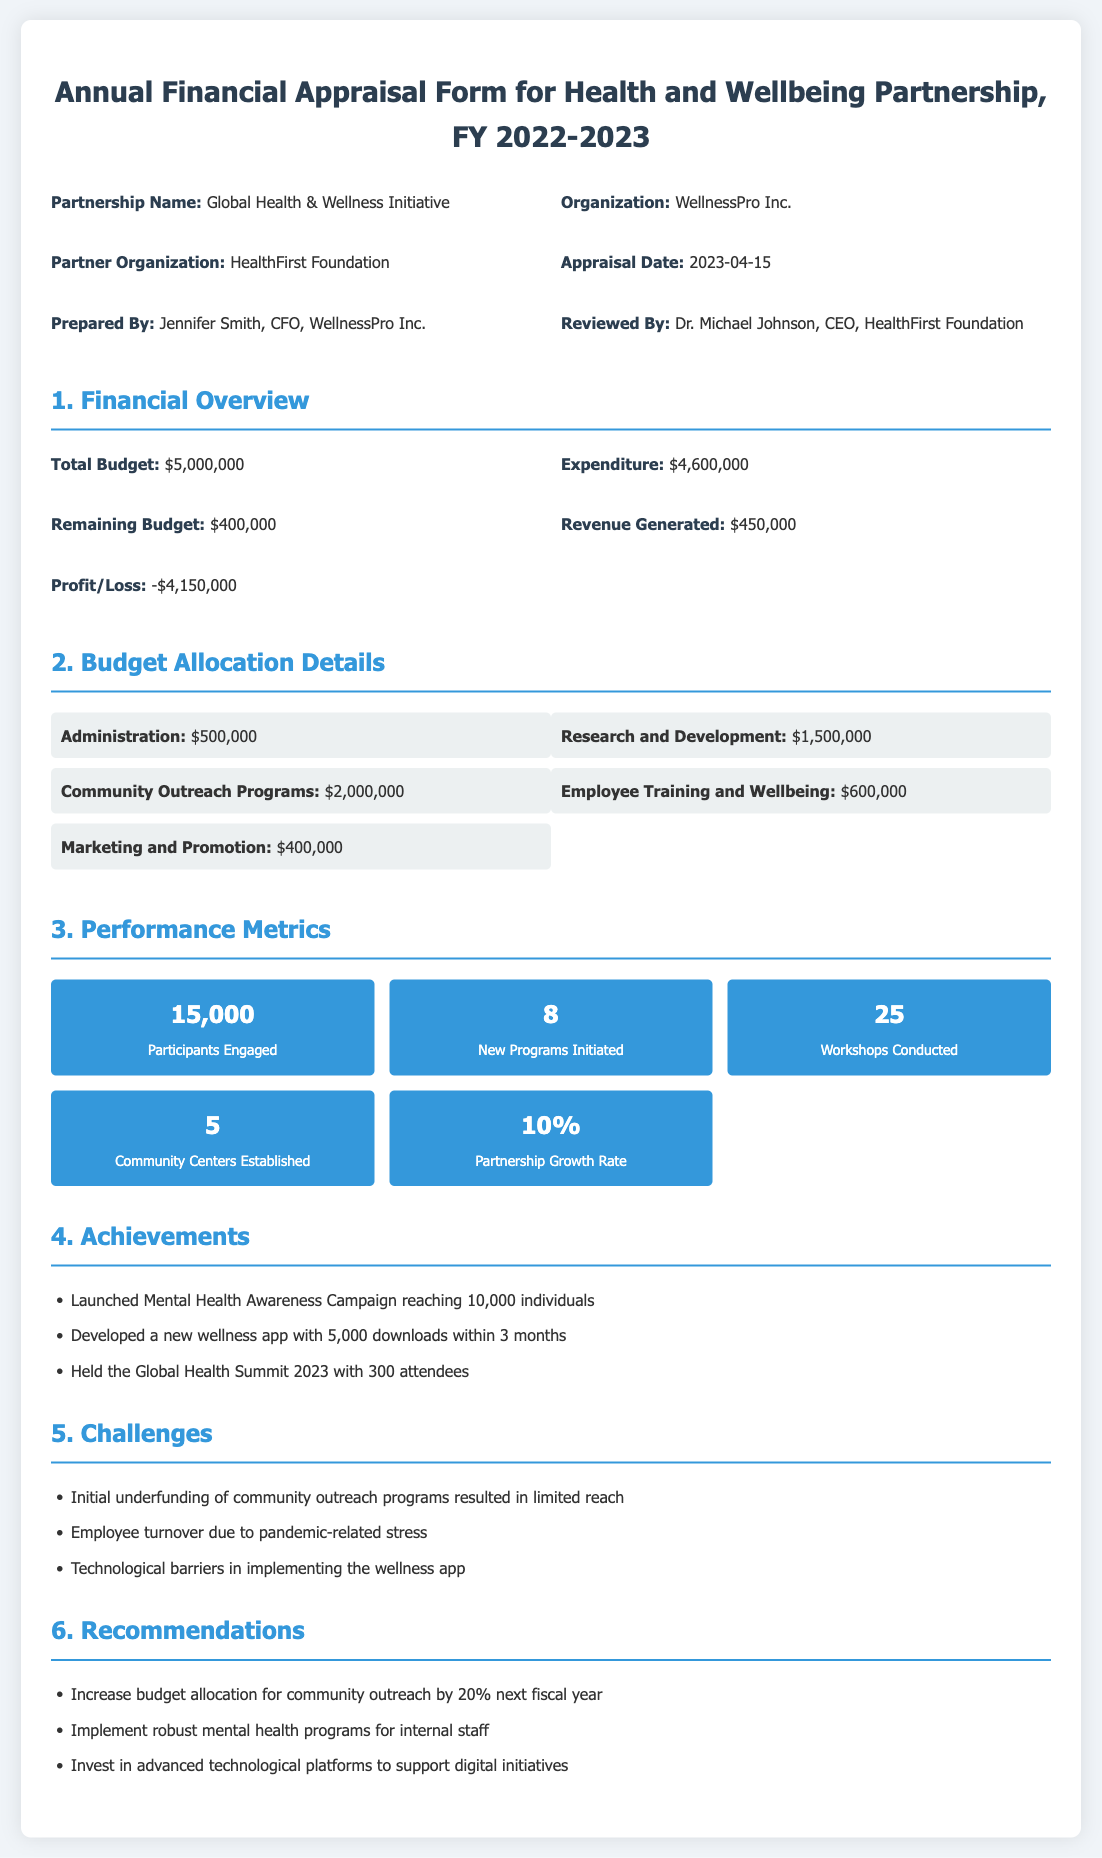What is the partnership name? The partnership name is stated at the beginning of the document, which is Global Health & Wellness Initiative.
Answer: Global Health & Wellness Initiative What is the total budget allocated? The total budget available according to the financial overview section in the document is $5,000,000.
Answer: $5,000,000 Who prepared the appraisal? The name of the individual who prepared the appraisal form is Jennifer Smith, who is the CFO of WellnessPro Inc.
Answer: Jennifer Smith What is the profit or loss reported? The document states a loss of $4,150,000 under the financial overview section.
Answer: -$4,150,000 How much is allocated to Community Outreach Programs? The budget allocation for Community Outreach Programs can be found in the budget details and is $2,000,000.
Answer: $2,000,000 How many participants were engaged? The performance metric for participants engaged is prominently listed as 15,000.
Answer: 15,000 What is the recommendation for next fiscal year's community outreach budget? The recommendation indicates to increase the community outreach budget allocation by 20% next fiscal year.
Answer: Increase by 20% What was a major challenge faced during the year? One challenge mentioned in the document is the initial underfunding of community outreach programs, which limited their reach.
Answer: Initial underfunding How many new programs were initiated? The number of new programs initiated, as stated in the performance metrics, is 8.
Answer: 8 What was the growth rate of the partnership? The partnership growth rate, according to the metrics, is indicated as 10%.
Answer: 10% 